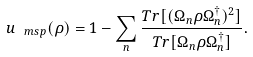Convert formula to latex. <formula><loc_0><loc_0><loc_500><loc_500>u _ { \ m s { p } } ( \rho ) = 1 - \sum _ { n } \frac { T r [ ( \Omega _ { n } \rho \Omega _ { n } ^ { \dagger } ) ^ { 2 } ] } { T r [ \Omega _ { n } \rho \Omega _ { n } ^ { \dagger } ] } .</formula> 